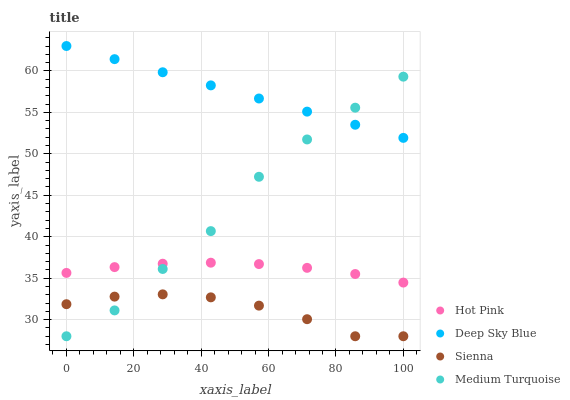Does Sienna have the minimum area under the curve?
Answer yes or no. Yes. Does Deep Sky Blue have the maximum area under the curve?
Answer yes or no. Yes. Does Hot Pink have the minimum area under the curve?
Answer yes or no. No. Does Hot Pink have the maximum area under the curve?
Answer yes or no. No. Is Deep Sky Blue the smoothest?
Answer yes or no. Yes. Is Medium Turquoise the roughest?
Answer yes or no. Yes. Is Hot Pink the smoothest?
Answer yes or no. No. Is Hot Pink the roughest?
Answer yes or no. No. Does Sienna have the lowest value?
Answer yes or no. Yes. Does Hot Pink have the lowest value?
Answer yes or no. No. Does Deep Sky Blue have the highest value?
Answer yes or no. Yes. Does Hot Pink have the highest value?
Answer yes or no. No. Is Hot Pink less than Deep Sky Blue?
Answer yes or no. Yes. Is Hot Pink greater than Sienna?
Answer yes or no. Yes. Does Deep Sky Blue intersect Medium Turquoise?
Answer yes or no. Yes. Is Deep Sky Blue less than Medium Turquoise?
Answer yes or no. No. Is Deep Sky Blue greater than Medium Turquoise?
Answer yes or no. No. Does Hot Pink intersect Deep Sky Blue?
Answer yes or no. No. 